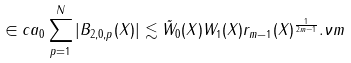<formula> <loc_0><loc_0><loc_500><loc_500>\in c a _ { 0 } \sum _ { p = 1 } ^ { N } | B _ { 2 , 0 , p } ( X ) | \lesssim \tilde { W } _ { 0 } ( X ) W _ { 1 } ( X ) r _ { m - 1 } ( X ) ^ { \frac { 1 } { 2 m - 1 } } . \nu m</formula> 